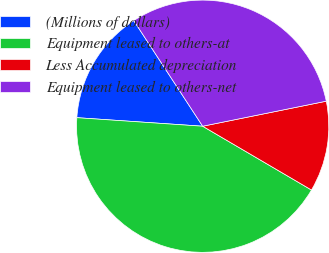<chart> <loc_0><loc_0><loc_500><loc_500><pie_chart><fcel>(Millions of dollars)<fcel>Equipment leased to others-at<fcel>Less Accumulated depreciation<fcel>Equipment leased to others-net<nl><fcel>14.72%<fcel>42.64%<fcel>11.62%<fcel>31.02%<nl></chart> 